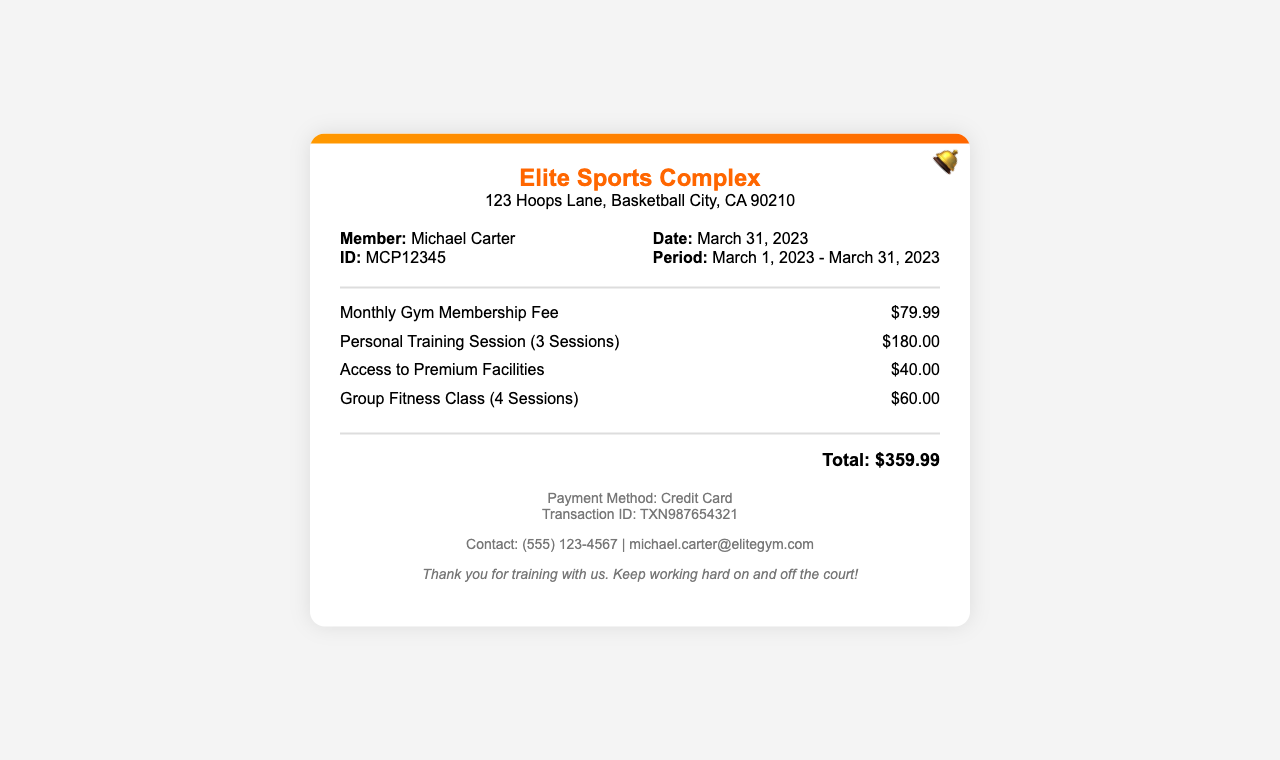What is the member ID? The member ID is listed in the member information section of the receipt.
Answer: MCP12345 What is the date of the receipt? The date of the receipt is found in the member information section.
Answer: March 31, 2023 How many personal training sessions were included? The number of personal training sessions is specified in the charges section as part of the fee description.
Answer: 3 Sessions What is the total amount charged? The total amount charged is summarized at the bottom of the receipt for all charges.
Answer: $359.99 What type of payment method was used? The payment method is indicated in the footer section of the receipt.
Answer: Credit Card How much did the access to premium facilities cost? The cost for access to premium facilities is detailed in the charges section of the receipt.
Answer: $40.00 What is the contact email provided? The contact email is found in the footer of the receipt.
Answer: michael.carter@elitegym.com How many group fitness classes were included? The number of group fitness classes is stated in the charges section alongside their cost.
Answer: 4 Sessions What is the address of the gym? The gym's address is displayed in the header of the receipt.
Answer: 123 Hoops Lane, Basketball City, CA 90210 